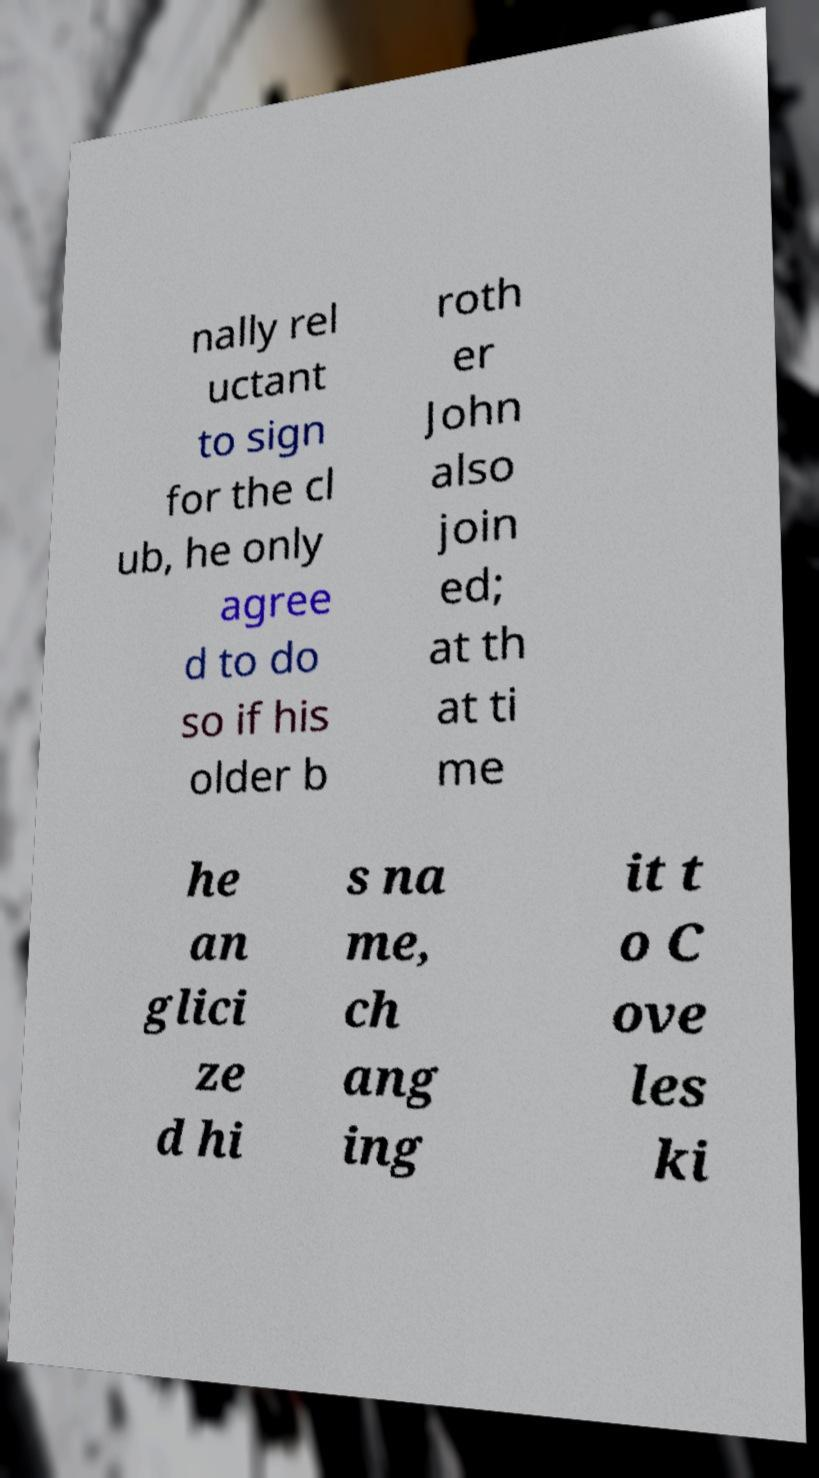Could you assist in decoding the text presented in this image and type it out clearly? nally rel uctant to sign for the cl ub, he only agree d to do so if his older b roth er John also join ed; at th at ti me he an glici ze d hi s na me, ch ang ing it t o C ove les ki 